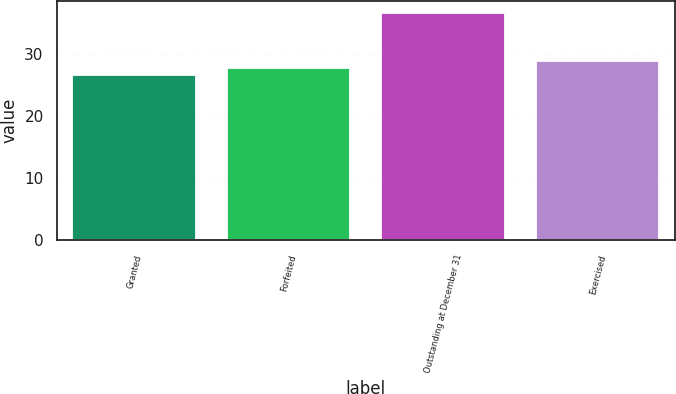Convert chart to OTSL. <chart><loc_0><loc_0><loc_500><loc_500><bar_chart><fcel>Granted<fcel>Forfeited<fcel>Outstanding at December 31<fcel>Exercised<nl><fcel>26.56<fcel>27.68<fcel>36.67<fcel>28.8<nl></chart> 